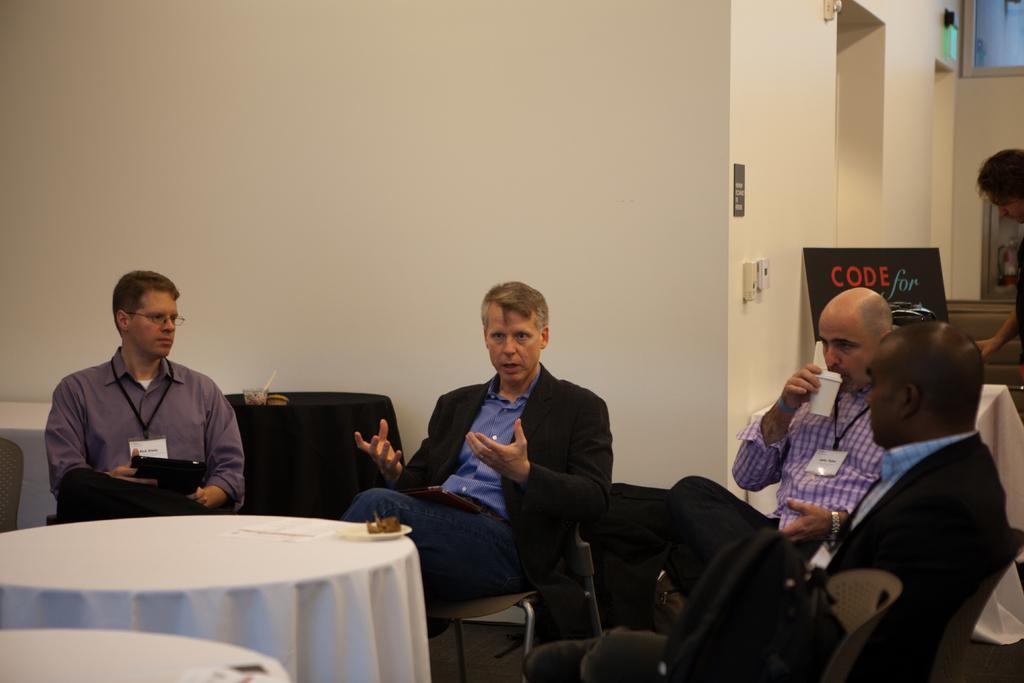Could you give a brief overview of what you see in this image? In this image I can see few men are sitting on chairs. I can also see few tables and a person in the background. 